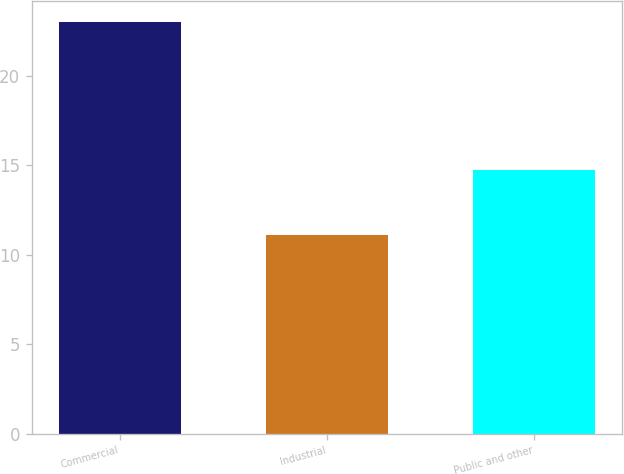<chart> <loc_0><loc_0><loc_500><loc_500><bar_chart><fcel>Commercial<fcel>Industrial<fcel>Public and other<nl><fcel>23<fcel>11.1<fcel>14.7<nl></chart> 